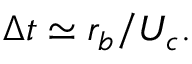<formula> <loc_0><loc_0><loc_500><loc_500>\Delta t \simeq { r _ { b } } / { U _ { c } } .</formula> 